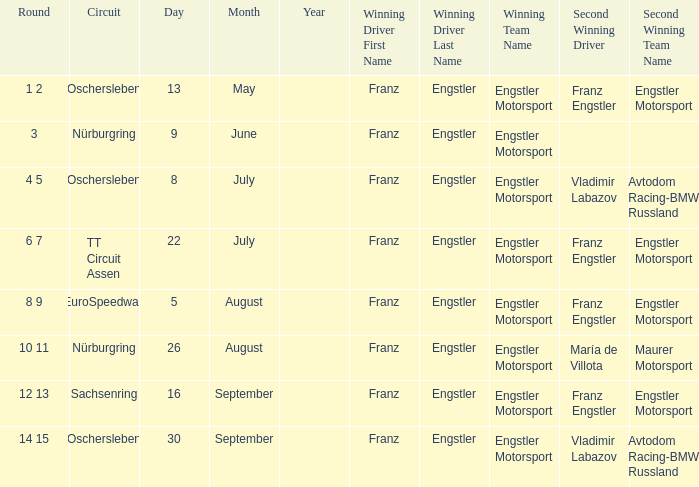Who is the Winning Driver that has a Winning team of Engstler Motorsport Engstler Motorsport and also the Date 22 July? Franz Engstler Franz Engstler. 